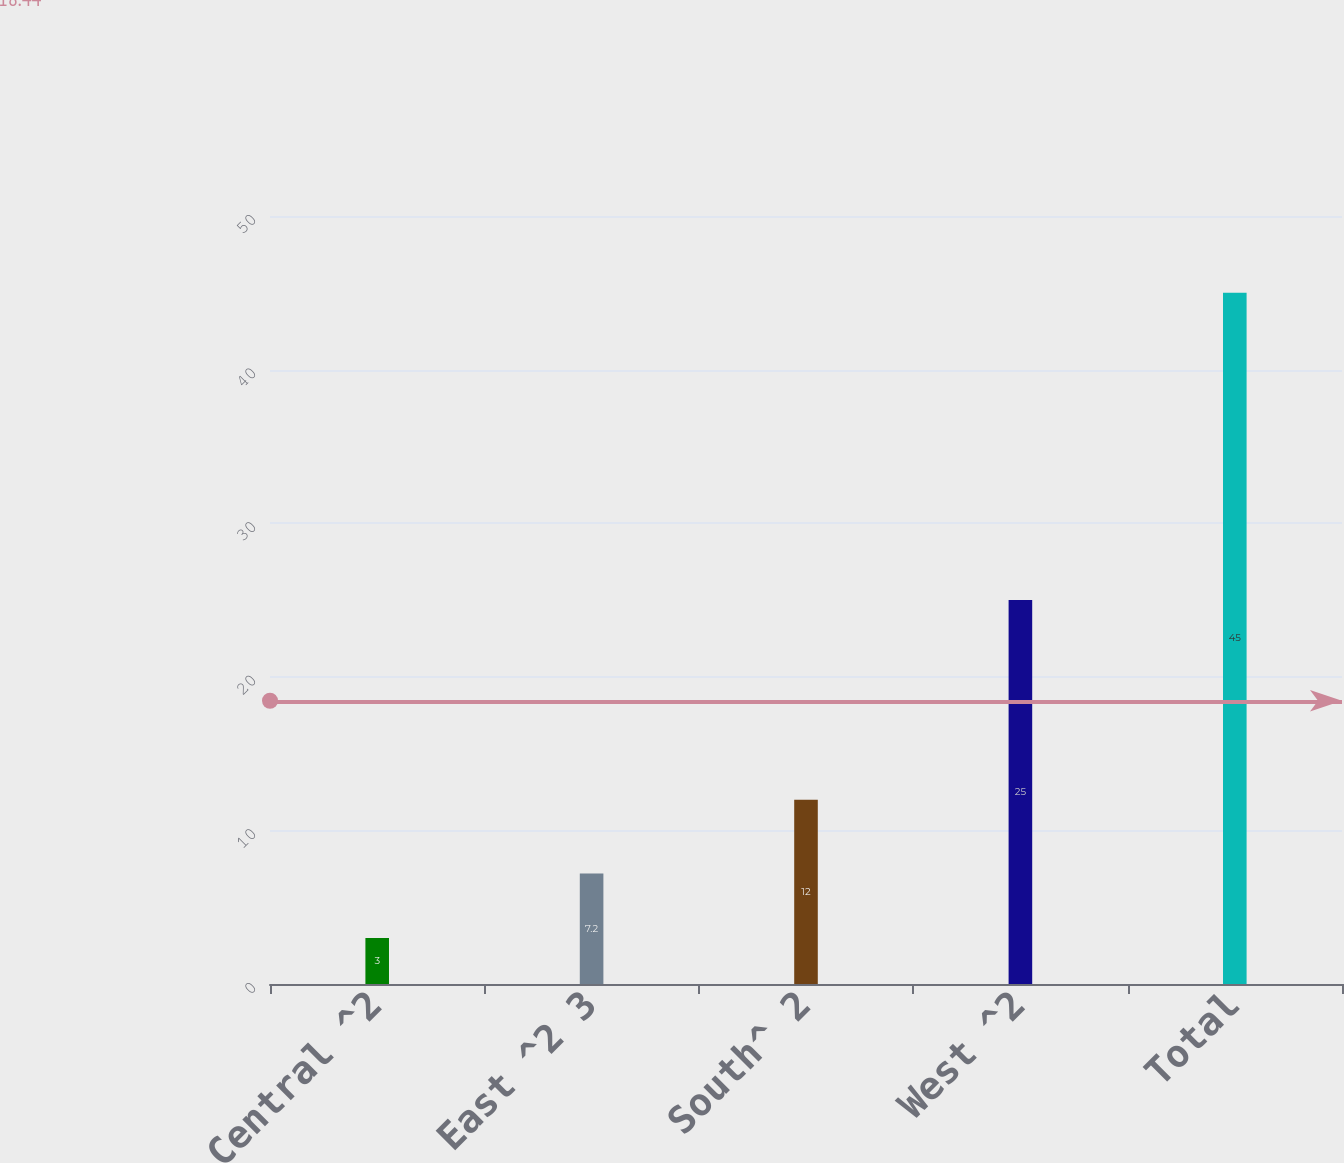Convert chart. <chart><loc_0><loc_0><loc_500><loc_500><bar_chart><fcel>Central ^2<fcel>East ^2 3<fcel>South^ 2<fcel>West ^2<fcel>Total<nl><fcel>3<fcel>7.2<fcel>12<fcel>25<fcel>45<nl></chart> 